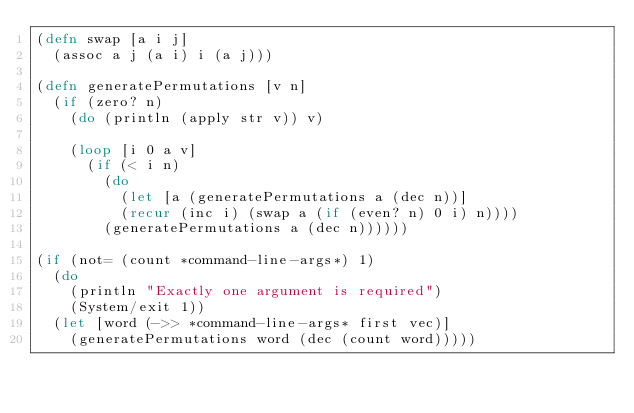Convert code to text. <code><loc_0><loc_0><loc_500><loc_500><_Clojure_>(defn swap [a i j]
  (assoc a j (a i) i (a j)))

(defn generatePermutations [v n]
  (if (zero? n)
    (do (println (apply str v)) v)

    (loop [i 0 a v]
      (if (< i n)
        (do
          (let [a (generatePermutations a (dec n))]
          (recur (inc i) (swap a (if (even? n) 0 i) n))))
        (generatePermutations a (dec n))))))

(if (not= (count *command-line-args*) 1)
  (do
    (println "Exactly one argument is required")
    (System/exit 1))
  (let [word (->> *command-line-args* first vec)]
    (generatePermutations word (dec (count word)))))
</code> 